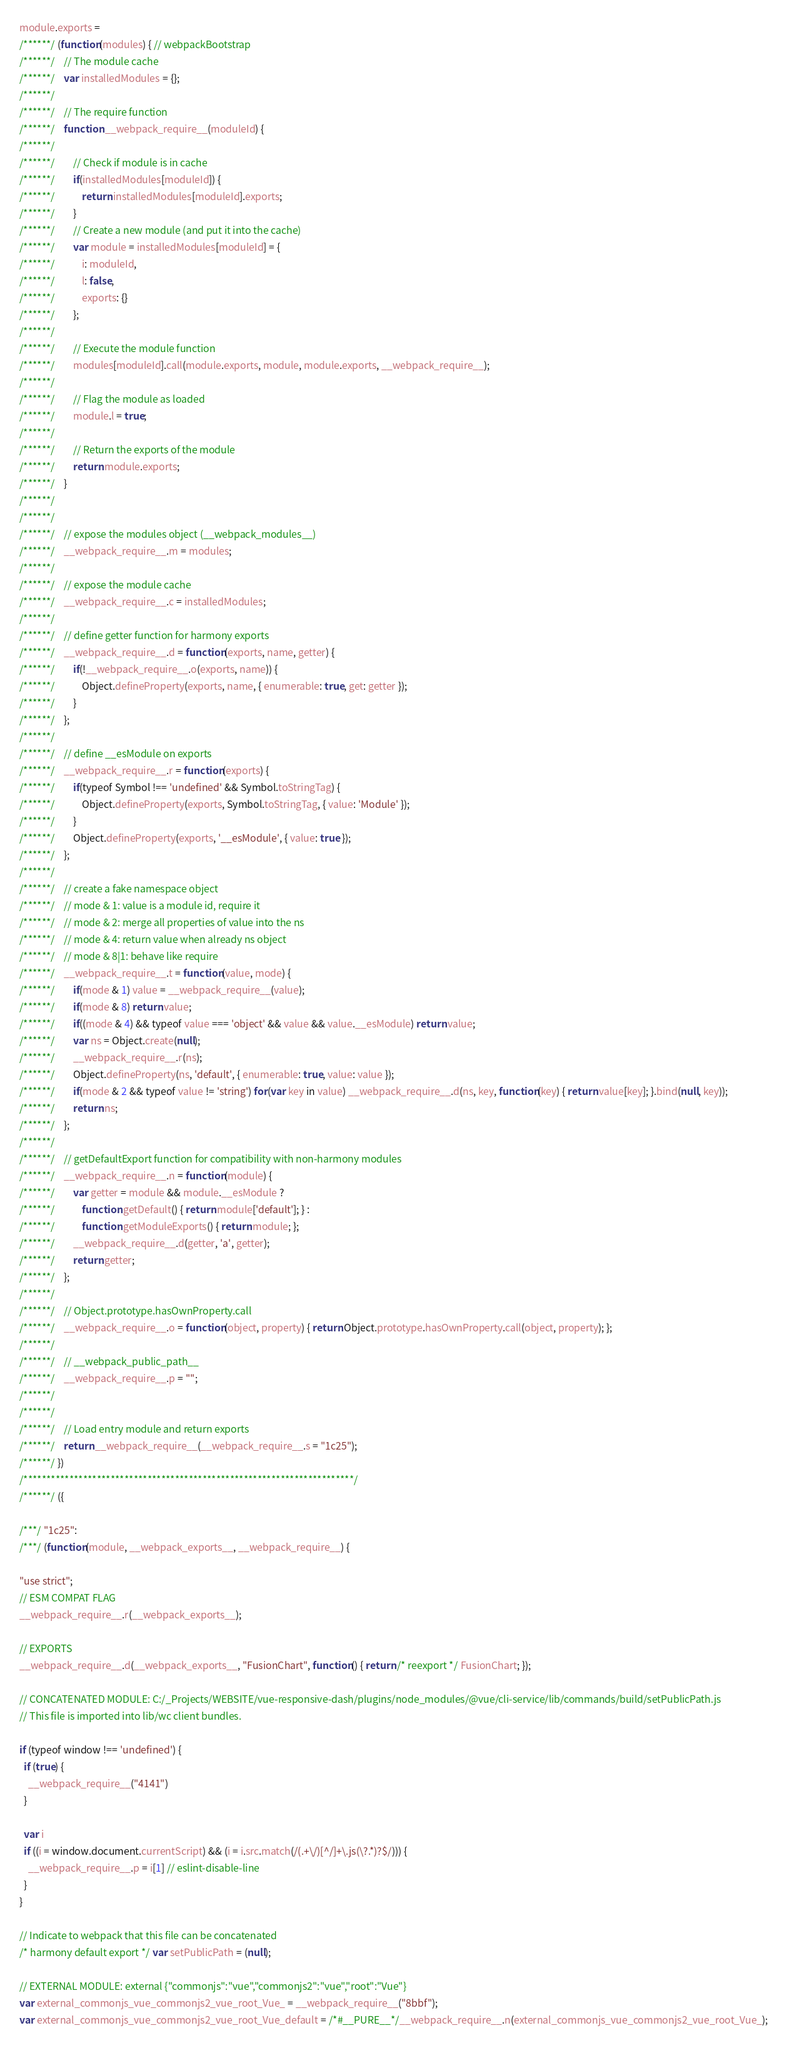Convert code to text. <code><loc_0><loc_0><loc_500><loc_500><_JavaScript_>module.exports =
/******/ (function(modules) { // webpackBootstrap
/******/ 	// The module cache
/******/ 	var installedModules = {};
/******/
/******/ 	// The require function
/******/ 	function __webpack_require__(moduleId) {
/******/
/******/ 		// Check if module is in cache
/******/ 		if(installedModules[moduleId]) {
/******/ 			return installedModules[moduleId].exports;
/******/ 		}
/******/ 		// Create a new module (and put it into the cache)
/******/ 		var module = installedModules[moduleId] = {
/******/ 			i: moduleId,
/******/ 			l: false,
/******/ 			exports: {}
/******/ 		};
/******/
/******/ 		// Execute the module function
/******/ 		modules[moduleId].call(module.exports, module, module.exports, __webpack_require__);
/******/
/******/ 		// Flag the module as loaded
/******/ 		module.l = true;
/******/
/******/ 		// Return the exports of the module
/******/ 		return module.exports;
/******/ 	}
/******/
/******/
/******/ 	// expose the modules object (__webpack_modules__)
/******/ 	__webpack_require__.m = modules;
/******/
/******/ 	// expose the module cache
/******/ 	__webpack_require__.c = installedModules;
/******/
/******/ 	// define getter function for harmony exports
/******/ 	__webpack_require__.d = function(exports, name, getter) {
/******/ 		if(!__webpack_require__.o(exports, name)) {
/******/ 			Object.defineProperty(exports, name, { enumerable: true, get: getter });
/******/ 		}
/******/ 	};
/******/
/******/ 	// define __esModule on exports
/******/ 	__webpack_require__.r = function(exports) {
/******/ 		if(typeof Symbol !== 'undefined' && Symbol.toStringTag) {
/******/ 			Object.defineProperty(exports, Symbol.toStringTag, { value: 'Module' });
/******/ 		}
/******/ 		Object.defineProperty(exports, '__esModule', { value: true });
/******/ 	};
/******/
/******/ 	// create a fake namespace object
/******/ 	// mode & 1: value is a module id, require it
/******/ 	// mode & 2: merge all properties of value into the ns
/******/ 	// mode & 4: return value when already ns object
/******/ 	// mode & 8|1: behave like require
/******/ 	__webpack_require__.t = function(value, mode) {
/******/ 		if(mode & 1) value = __webpack_require__(value);
/******/ 		if(mode & 8) return value;
/******/ 		if((mode & 4) && typeof value === 'object' && value && value.__esModule) return value;
/******/ 		var ns = Object.create(null);
/******/ 		__webpack_require__.r(ns);
/******/ 		Object.defineProperty(ns, 'default', { enumerable: true, value: value });
/******/ 		if(mode & 2 && typeof value != 'string') for(var key in value) __webpack_require__.d(ns, key, function(key) { return value[key]; }.bind(null, key));
/******/ 		return ns;
/******/ 	};
/******/
/******/ 	// getDefaultExport function for compatibility with non-harmony modules
/******/ 	__webpack_require__.n = function(module) {
/******/ 		var getter = module && module.__esModule ?
/******/ 			function getDefault() { return module['default']; } :
/******/ 			function getModuleExports() { return module; };
/******/ 		__webpack_require__.d(getter, 'a', getter);
/******/ 		return getter;
/******/ 	};
/******/
/******/ 	// Object.prototype.hasOwnProperty.call
/******/ 	__webpack_require__.o = function(object, property) { return Object.prototype.hasOwnProperty.call(object, property); };
/******/
/******/ 	// __webpack_public_path__
/******/ 	__webpack_require__.p = "";
/******/
/******/
/******/ 	// Load entry module and return exports
/******/ 	return __webpack_require__(__webpack_require__.s = "1c25");
/******/ })
/************************************************************************/
/******/ ({

/***/ "1c25":
/***/ (function(module, __webpack_exports__, __webpack_require__) {

"use strict";
// ESM COMPAT FLAG
__webpack_require__.r(__webpack_exports__);

// EXPORTS
__webpack_require__.d(__webpack_exports__, "FusionChart", function() { return /* reexport */ FusionChart; });

// CONCATENATED MODULE: C:/_Projects/WEBSITE/vue-responsive-dash/plugins/node_modules/@vue/cli-service/lib/commands/build/setPublicPath.js
// This file is imported into lib/wc client bundles.

if (typeof window !== 'undefined') {
  if (true) {
    __webpack_require__("4141")
  }

  var i
  if ((i = window.document.currentScript) && (i = i.src.match(/(.+\/)[^/]+\.js(\?.*)?$/))) {
    __webpack_require__.p = i[1] // eslint-disable-line
  }
}

// Indicate to webpack that this file can be concatenated
/* harmony default export */ var setPublicPath = (null);

// EXTERNAL MODULE: external {"commonjs":"vue","commonjs2":"vue","root":"Vue"}
var external_commonjs_vue_commonjs2_vue_root_Vue_ = __webpack_require__("8bbf");
var external_commonjs_vue_commonjs2_vue_root_Vue_default = /*#__PURE__*/__webpack_require__.n(external_commonjs_vue_commonjs2_vue_root_Vue_);
</code> 